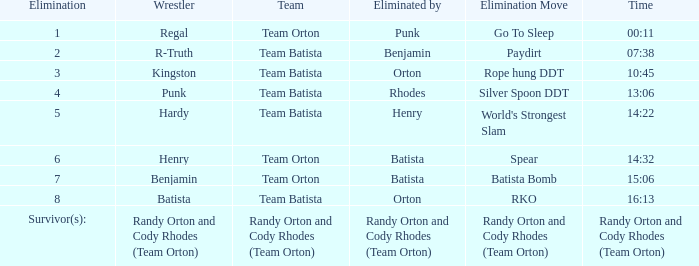Parse the table in full. {'header': ['Elimination', 'Wrestler', 'Team', 'Eliminated by', 'Elimination Move', 'Time'], 'rows': [['1', 'Regal', 'Team Orton', 'Punk', 'Go To Sleep', '00:11'], ['2', 'R-Truth', 'Team Batista', 'Benjamin', 'Paydirt', '07:38'], ['3', 'Kingston', 'Team Batista', 'Orton', 'Rope hung DDT', '10:45'], ['4', 'Punk', 'Team Batista', 'Rhodes', 'Silver Spoon DDT', '13:06'], ['5', 'Hardy', 'Team Batista', 'Henry', "World's Strongest Slam", '14:22'], ['6', 'Henry', 'Team Orton', 'Batista', 'Spear', '14:32'], ['7', 'Benjamin', 'Team Orton', 'Batista', 'Batista Bomb', '15:06'], ['8', 'Batista', 'Team Batista', 'Orton', 'RKO', '16:13'], ['Survivor(s):', 'Randy Orton and Cody Rhodes (Team Orton)', 'Randy Orton and Cody Rhodes (Team Orton)', 'Randy Orton and Cody Rhodes (Team Orton)', 'Randy Orton and Cody Rhodes (Team Orton)', 'Randy Orton and Cody Rhodes (Team Orton)']]} Which Elimination move is listed against Team Orton, Eliminated by Batista against Elimination number 7? Batista Bomb. 